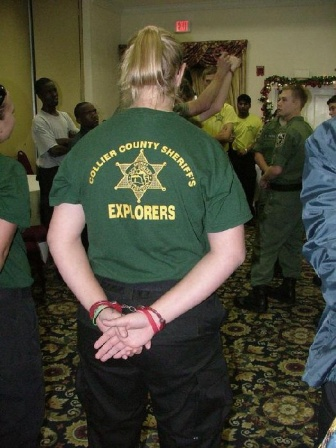What could be the role of the person observing the group? The person in the green t-shirt seems to have a supervisory or mentoring role within the group. Their shirt indicates affiliation with the 'Collier County Sheriff's Explorers,' which hints at a program likely associated with youth engagement or law enforcement training. Standing with their hands clasped and facing the group suggests they might be leading the event or ensuring everything runs smoothly, typical of someone in a leadership or guidance position. 